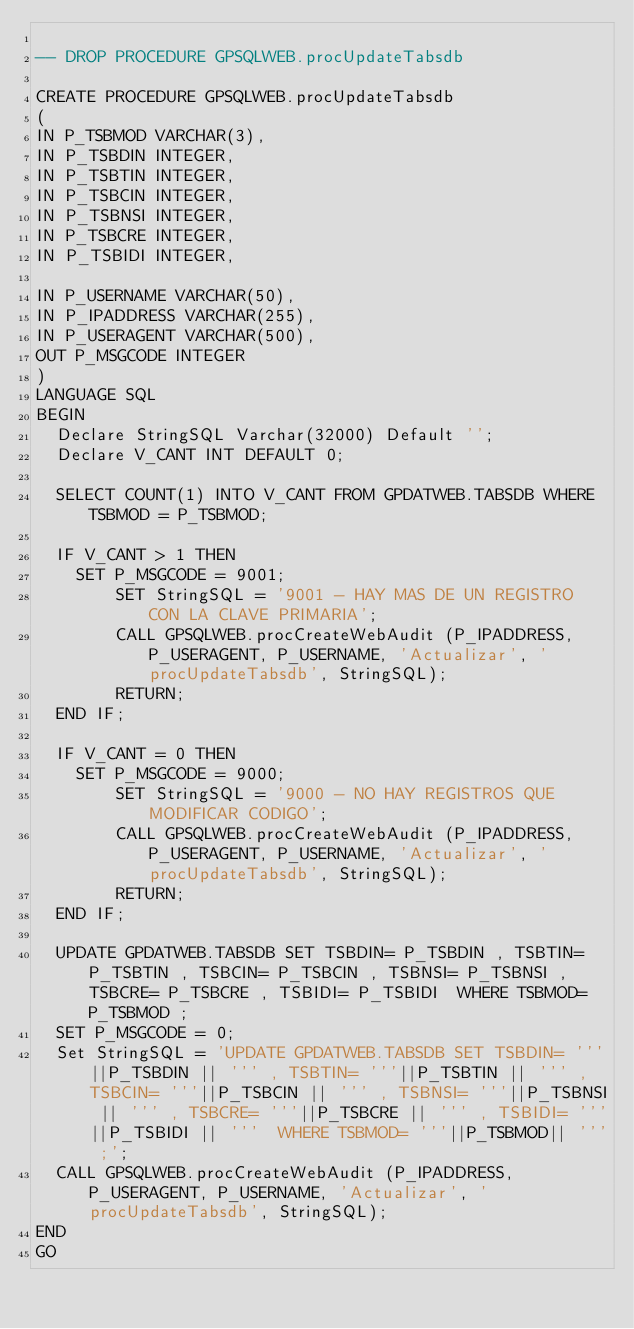<code> <loc_0><loc_0><loc_500><loc_500><_SQL_>
-- DROP PROCEDURE GPSQLWEB.procUpdateTabsdb
    
CREATE PROCEDURE GPSQLWEB.procUpdateTabsdb
(
IN P_TSBMOD VARCHAR(3),
IN P_TSBDIN INTEGER,
IN P_TSBTIN INTEGER,
IN P_TSBCIN INTEGER,
IN P_TSBNSI INTEGER,
IN P_TSBCRE INTEGER,
IN P_TSBIDI INTEGER,

IN P_USERNAME VARCHAR(50),
IN P_IPADDRESS VARCHAR(255),
IN P_USERAGENT VARCHAR(500),
OUT P_MSGCODE INTEGER
)
LANGUAGE SQL
BEGIN
  Declare StringSQL Varchar(32000) Default '';
  Declare V_CANT INT DEFAULT 0;
  
  SELECT COUNT(1) INTO V_CANT FROM GPDATWEB.TABSDB WHERE TSBMOD = P_TSBMOD;

  IF V_CANT > 1 THEN
	SET P_MSGCODE = 9001;
        SET StringSQL = '9001 - HAY MAS DE UN REGISTRO CON LA CLAVE PRIMARIA';
        CALL GPSQLWEB.procCreateWebAudit (P_IPADDRESS, P_USERAGENT, P_USERNAME, 'Actualizar', 'procUpdateTabsdb', StringSQL);
        RETURN;
  END IF;

  IF V_CANT = 0 THEN
	SET P_MSGCODE = 9000;
        SET StringSQL = '9000 - NO HAY REGISTROS QUE MODIFICAR CODIGO';
        CALL GPSQLWEB.procCreateWebAudit (P_IPADDRESS, P_USERAGENT, P_USERNAME, 'Actualizar', 'procUpdateTabsdb', StringSQL);
        RETURN;
  END IF;

  UPDATE GPDATWEB.TABSDB SET TSBDIN= P_TSBDIN , TSBTIN= P_TSBTIN , TSBCIN= P_TSBCIN , TSBNSI= P_TSBNSI , TSBCRE= P_TSBCRE , TSBIDI= P_TSBIDI  WHERE TSBMOD= P_TSBMOD ;
  SET P_MSGCODE = 0;    
  Set StringSQL = 'UPDATE GPDATWEB.TABSDB SET TSBDIN= '''||P_TSBDIN || ''' , TSBTIN= '''||P_TSBTIN || ''' , TSBCIN= '''||P_TSBCIN || ''' , TSBNSI= '''||P_TSBNSI || ''' , TSBCRE= '''||P_TSBCRE || ''' , TSBIDI= '''||P_TSBIDI || '''  WHERE TSBMOD= '''||P_TSBMOD|| ''' ;';
  CALL GPSQLWEB.procCreateWebAudit (P_IPADDRESS, P_USERAGENT, P_USERNAME, 'Actualizar', 'procUpdateTabsdb', StringSQL);
END
GO


</code> 